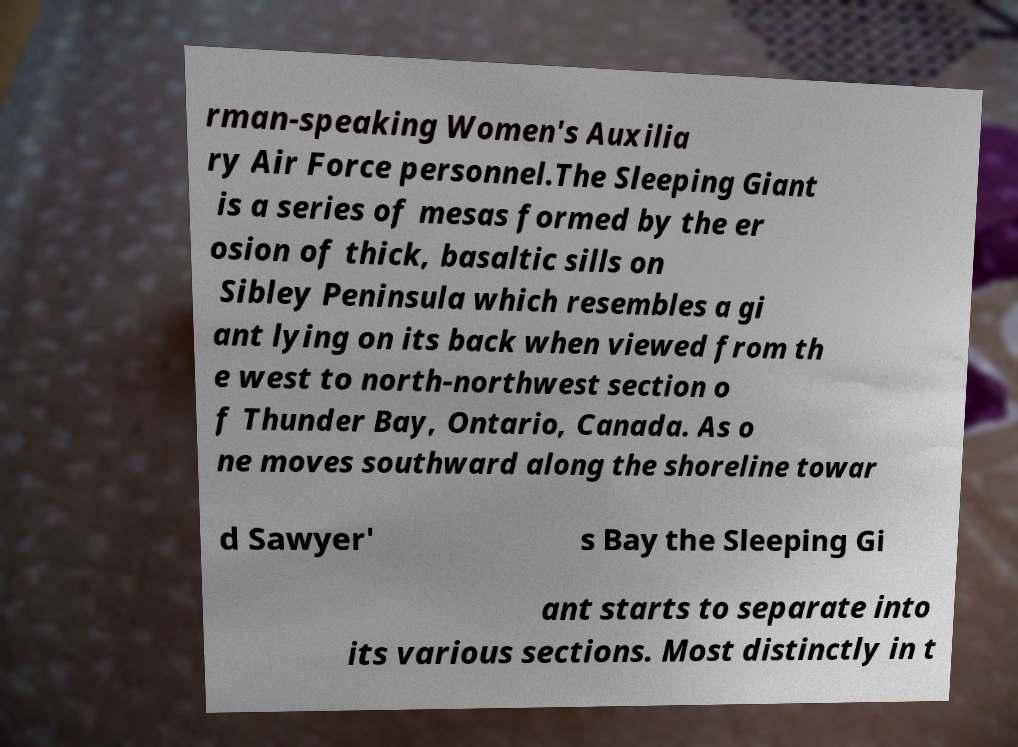Can you accurately transcribe the text from the provided image for me? rman-speaking Women's Auxilia ry Air Force personnel.The Sleeping Giant is a series of mesas formed by the er osion of thick, basaltic sills on Sibley Peninsula which resembles a gi ant lying on its back when viewed from th e west to north-northwest section o f Thunder Bay, Ontario, Canada. As o ne moves southward along the shoreline towar d Sawyer' s Bay the Sleeping Gi ant starts to separate into its various sections. Most distinctly in t 